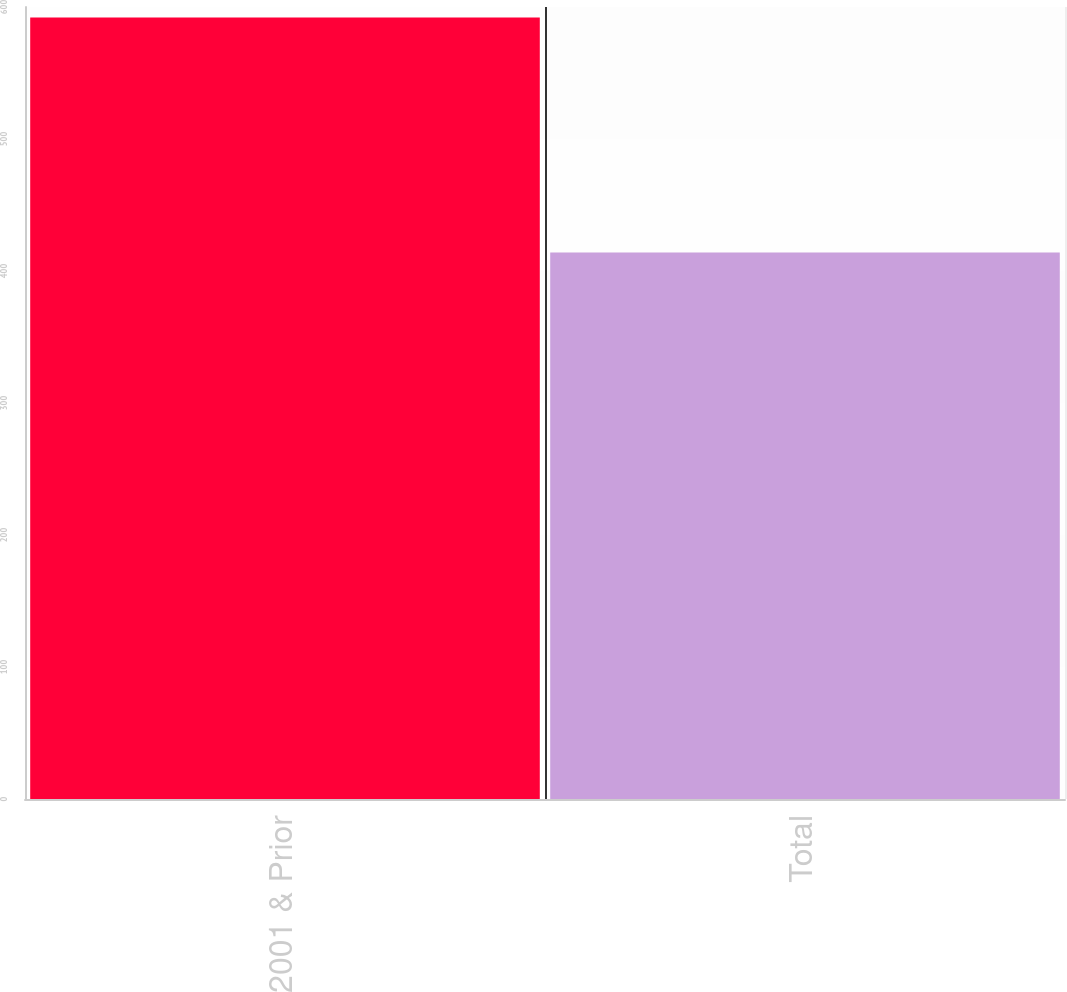Convert chart. <chart><loc_0><loc_0><loc_500><loc_500><bar_chart><fcel>2001 & Prior<fcel>Total<nl><fcel>592<fcel>414<nl></chart> 